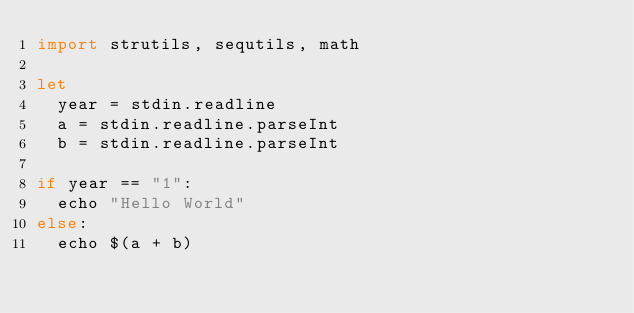<code> <loc_0><loc_0><loc_500><loc_500><_Nim_>import strutils, sequtils, math

let
  year = stdin.readline
  a = stdin.readline.parseInt
  b = stdin.readline.parseInt

if year == "1":
  echo "Hello World"
else:
  echo $(a + b)</code> 